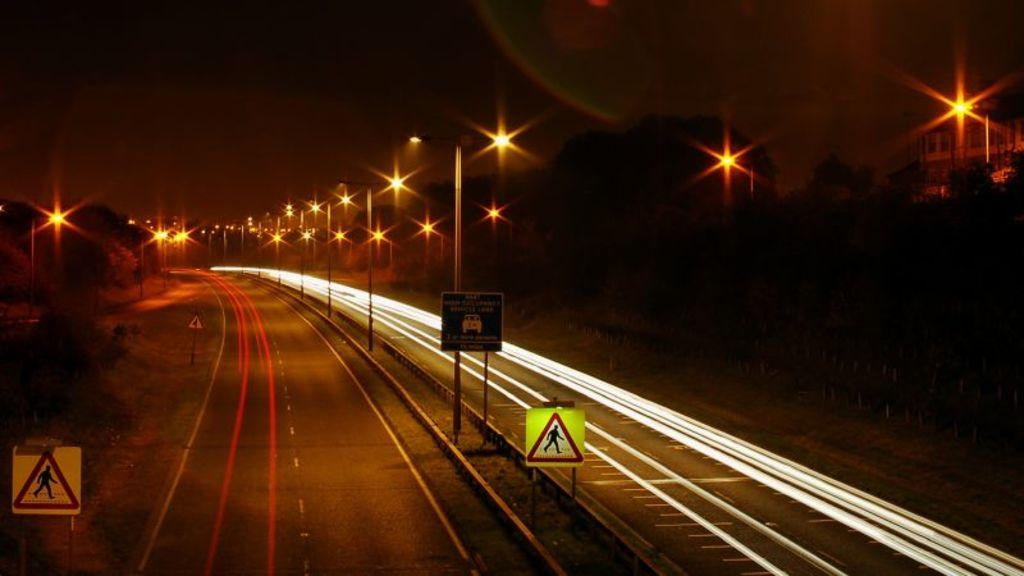What is the lighting condition in the image? The image is taken in the dark. What type of infrastructure can be seen in the image? There are roads and light poles visible in the image. What safety measures are present in the image? Caution boards are present in the image. What type of natural elements can be seen in the image? There are trees in the image. What is the color of the sky in the background of the image? The sky in the background is dark. What type of curtain can be seen hanging from the light poles in the image? There are no curtains present in the image; only light poles, roads, trees, and caution boards are visible. How many turkeys are visible in the image? There are no turkeys present in the image. 